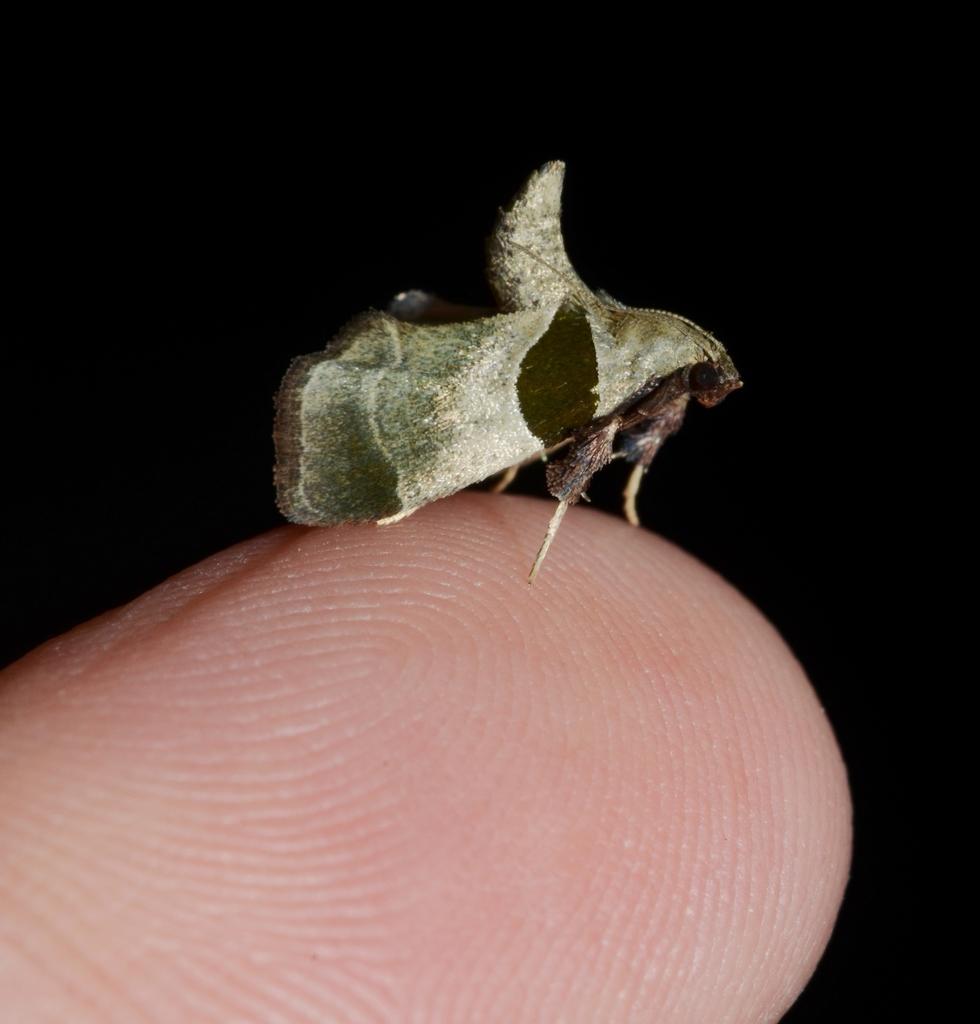Describe this image in one or two sentences. In this picture we can see a person´s finger, there is an insect present on the finger, there is a dark background. 